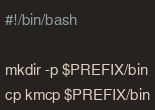<code> <loc_0><loc_0><loc_500><loc_500><_Bash_>#!/bin/bash

mkdir -p $PREFIX/bin
cp kmcp $PREFIX/bin
</code> 